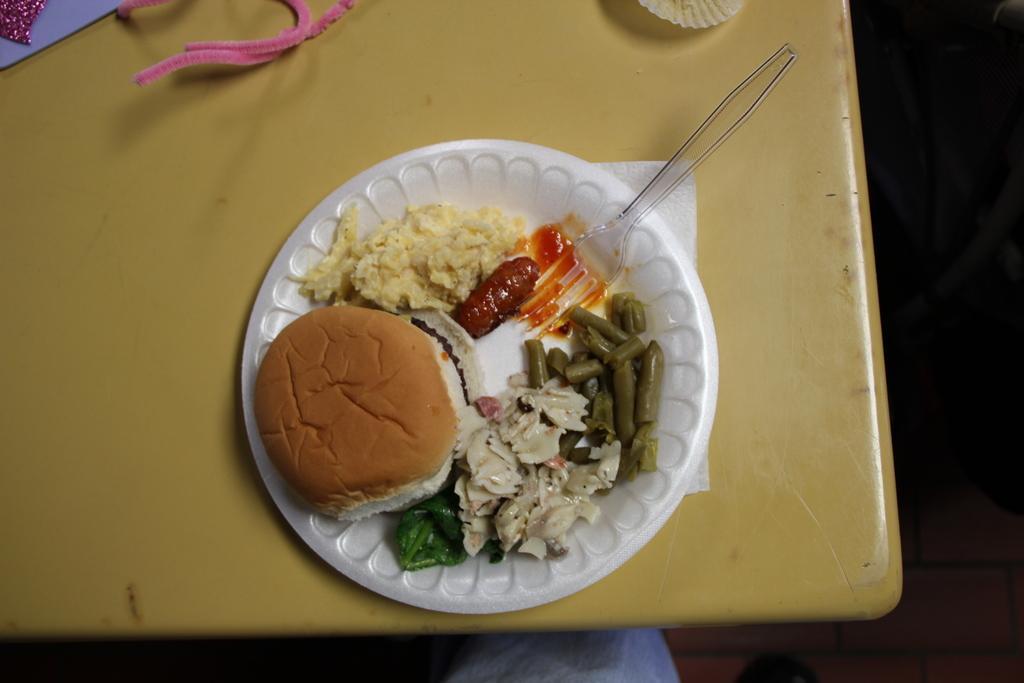Could you give a brief overview of what you see in this image? In this image I can see a cream colored table and on it I can see a white colored plate and in the plate I can see a bun which is brown and cream in color and few other food items which are yellow, red, orange, green and cream in color. I can see few other objects which are pink and purple in color. 